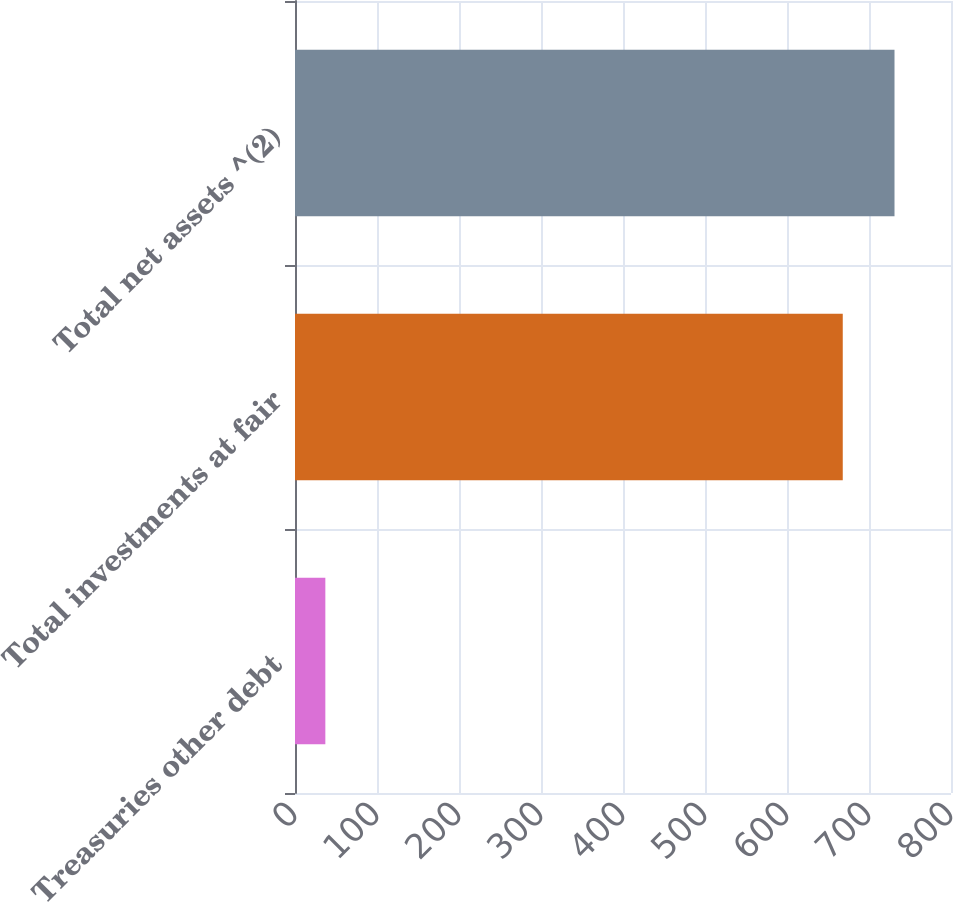Convert chart. <chart><loc_0><loc_0><loc_500><loc_500><bar_chart><fcel>Treasuries other debt<fcel>Total investments at fair<fcel>Total net assets ^(2)<nl><fcel>37<fcel>668<fcel>731.1<nl></chart> 